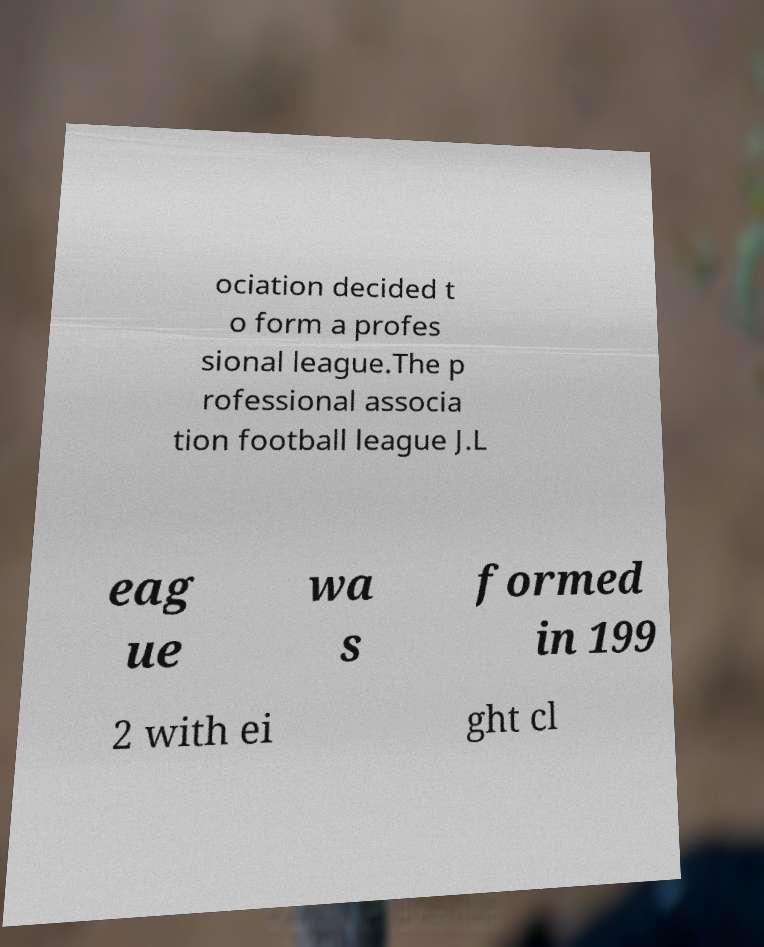Could you assist in decoding the text presented in this image and type it out clearly? ociation decided t o form a profes sional league.The p rofessional associa tion football league J.L eag ue wa s formed in 199 2 with ei ght cl 